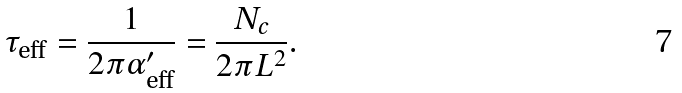Convert formula to latex. <formula><loc_0><loc_0><loc_500><loc_500>\tau _ { \text {eff} } = \frac { 1 } { 2 \pi \alpha _ { \text {eff} } ^ { \prime } } = \frac { N _ { c } } { 2 \pi L ^ { 2 } } .</formula> 